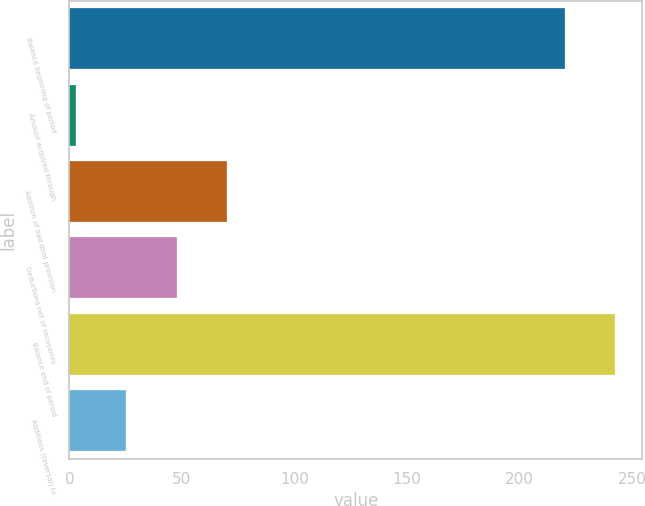Convert chart. <chart><loc_0><loc_0><loc_500><loc_500><bar_chart><fcel>Balance beginning of period<fcel>Amount acquired through<fcel>Addition of bad debt provision<fcel>Deductions net of recoveries<fcel>Balance end of period<fcel>Additions (reversal) to<nl><fcel>220<fcel>3<fcel>69.9<fcel>47.6<fcel>242.3<fcel>25.3<nl></chart> 